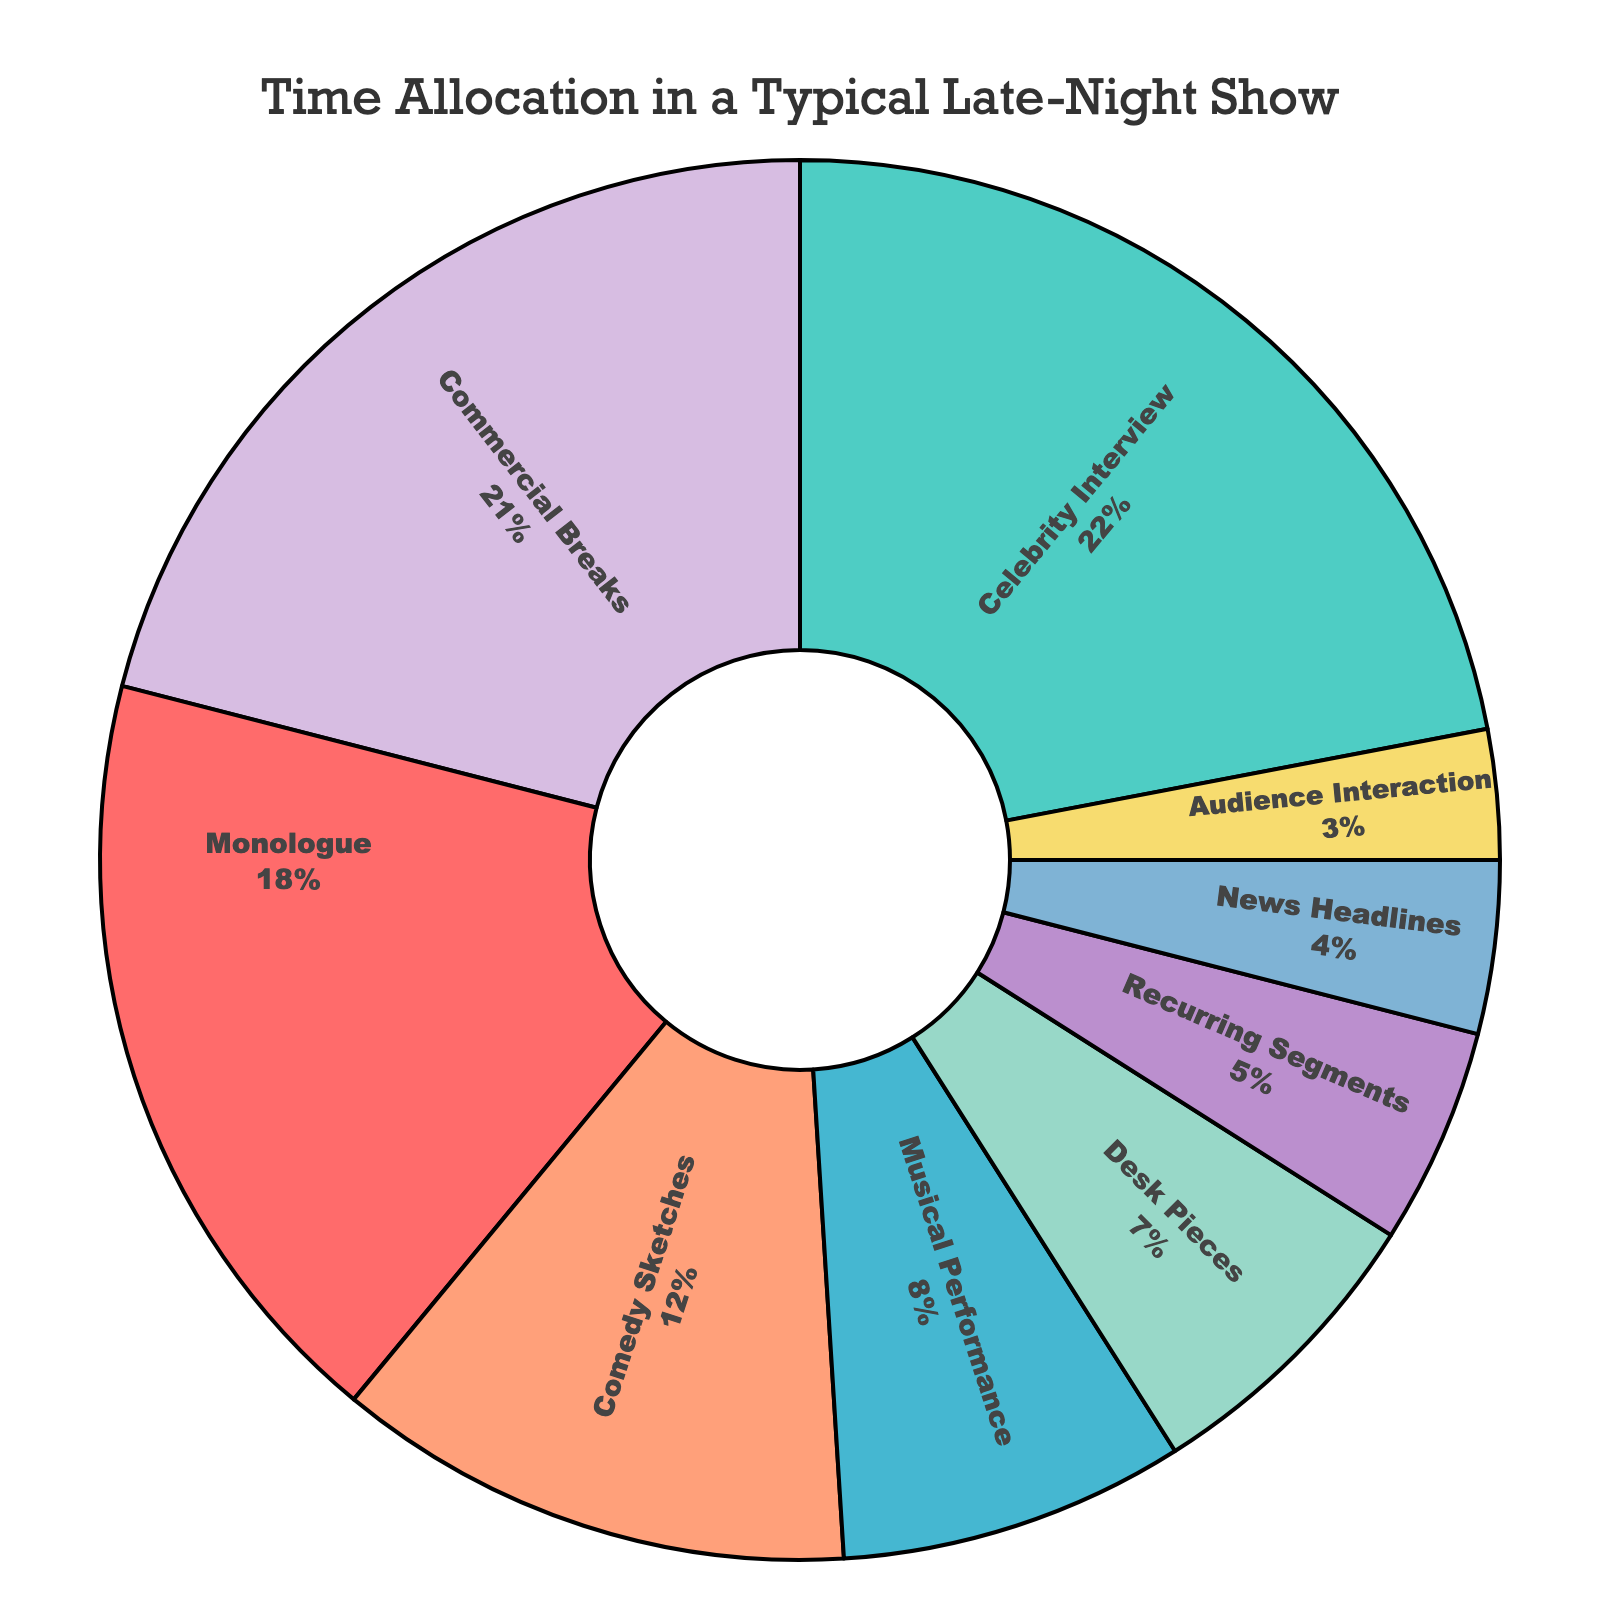What is the largest segment in the pie chart? By looking at the figure, find the segment that occupies the most screen time. The largest segment by percentage will be the one that visually appears the biggest.
Answer: Celebrity Interview What percentage of the show is allocated to Monologue? Locate the Monologue segment in the pie chart and read the percentage label inside the segment.
Answer: 18% How many total minutes are allocated to Desk Pieces and Audience Interaction combined? Find the minutes for Desk Pieces (7) and Audience Interaction (3) and sum them together.
Answer: 10 Which segment receives the least screen time? Identify the smallest segment in the pie chart. Visually, it should be the smallest slice, which represents the least number of minutes.
Answer: Audience Interaction How does the time allocated to Musical Performance compare to News Headlines? Find the minutes for both Musical Performance (8) and News Headlines (4) and compare them.
Answer: Musical Performance has 4 more minutes than News Headlines What is the sum of minutes allocated to Comedy Sketches, Desk Pieces, and Recurring Segments? Sum the minutes for Comedy Sketches (12), Desk Pieces (7), and Recurring Segments (5).
Answer: 24 Which color represents the Commercial Breaks segment? Visually identify the segment labeled "Commercial Breaks" and describe its color.
Answer: Blue How much more time is allocated to the Monologue compared to the Recurring Segments? Find the difference in the minutes between Monologue (18) and Recurring Segments (5).
Answer: 13 What is the total screen time for segments related to audience engagement (Audience Interaction + Recurring Segments)? Add the minutes for Audience Interaction (3) and Recurring Segments (5).
Answer: 8 Between Comedy Sketches and Celebrity Interview, which one takes up a larger portion of the show? Compare the percentages or minutes of Comedy Sketches (12) and Celebrity Interview (22) segments.
Answer: Celebrity Interview 